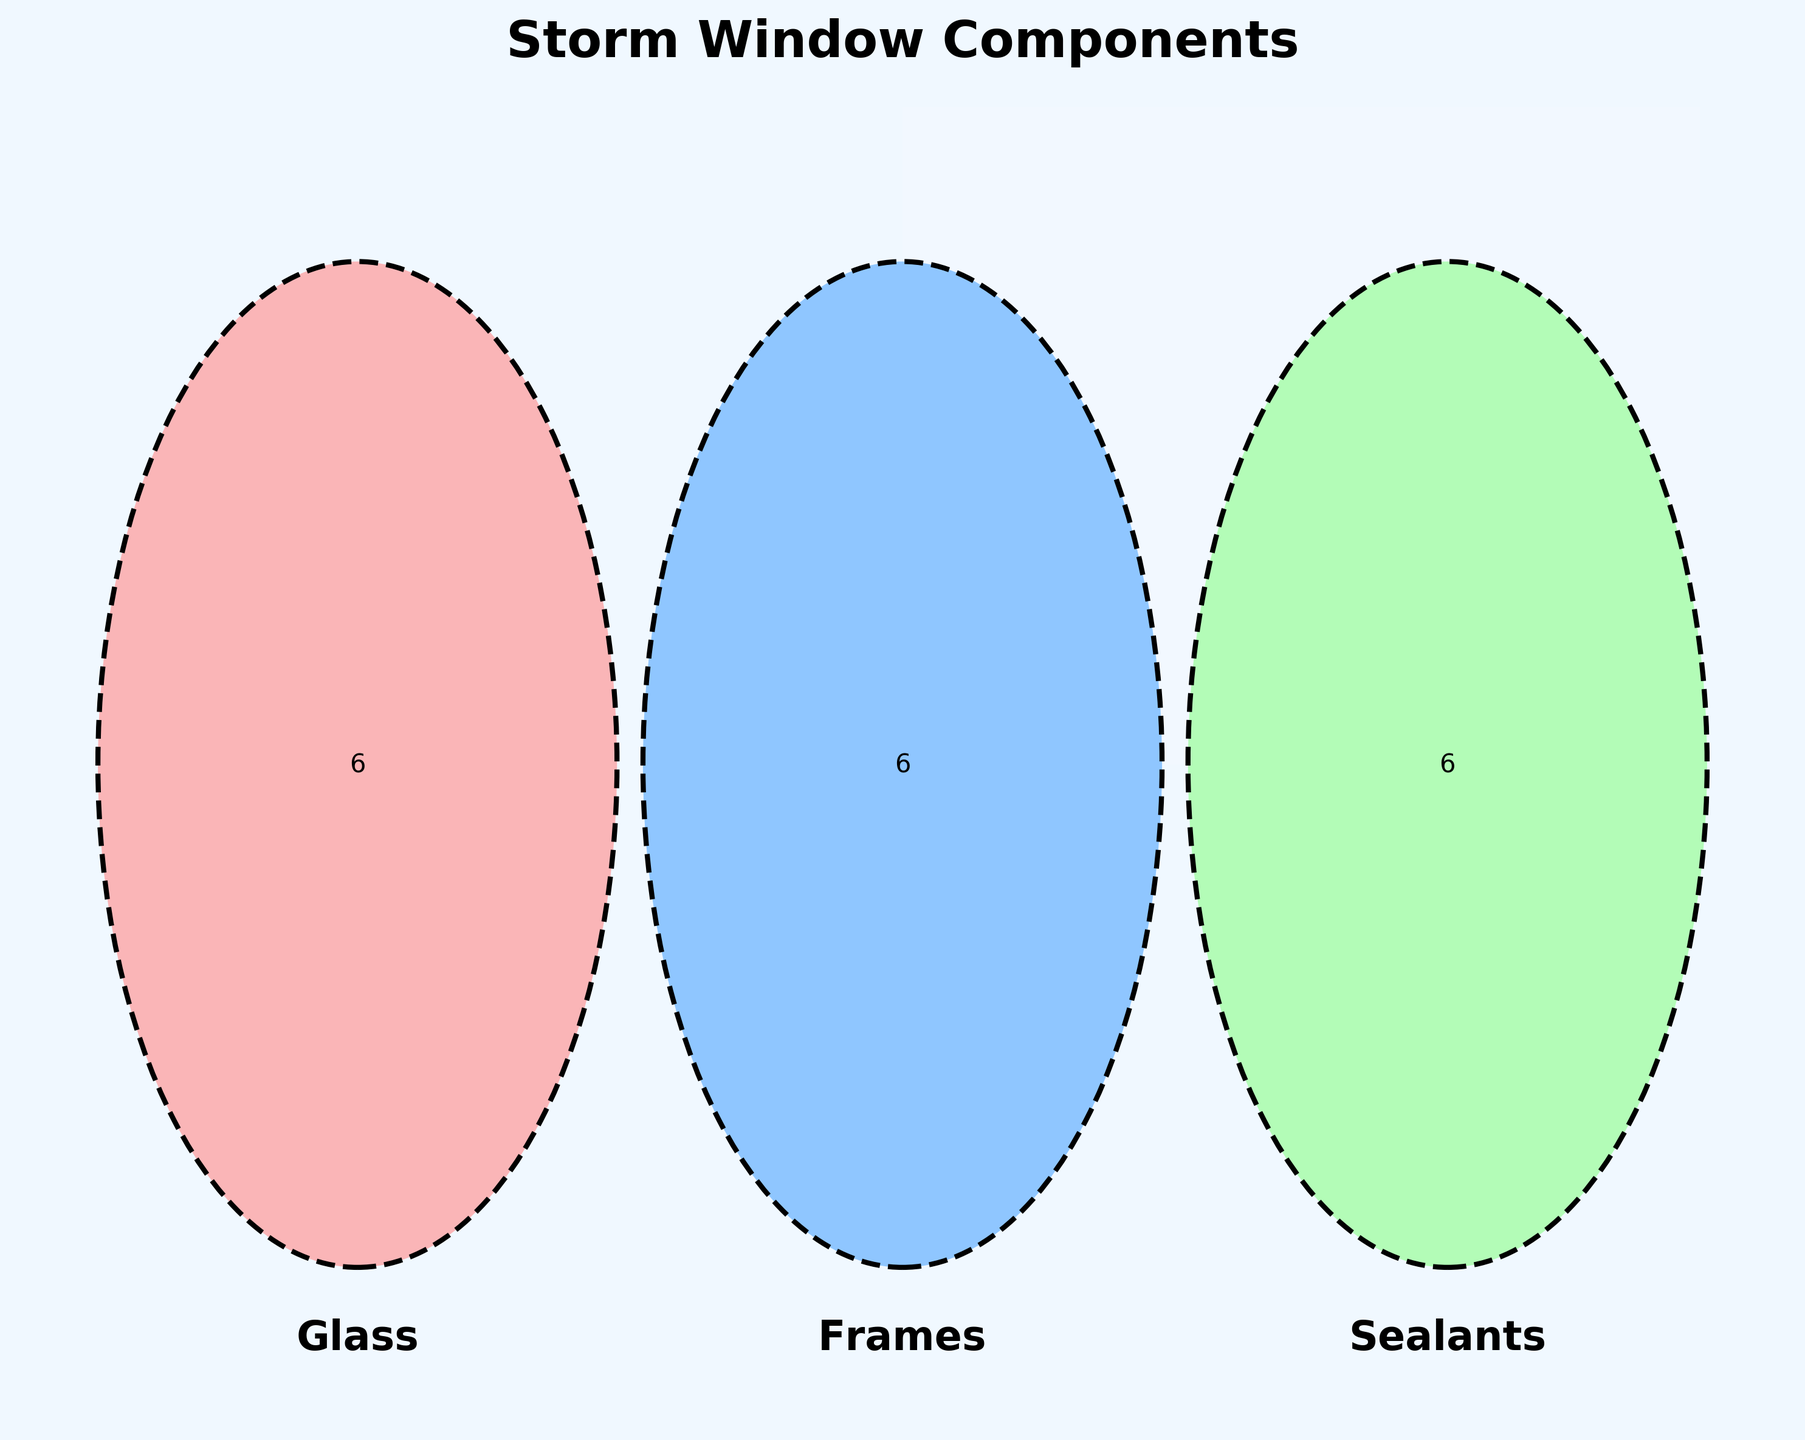What are the three main categories shown in the Venn Diagram? The Venn Diagram has labels indicating the three main categories represented by three circles. These labels are 'Glass', 'Frames', and 'Sealants'.
Answer: Glass, Frames, Sealants Identify one material that is only used in the 'Frames' category. The Venn Diagram shows that each category has unique materials. By looking specifically at the 'Frames' section (outside of any overlapping regions), we can identify unique materials like 'Aluminum', 'Vinyl', 'Fiberglass', 'Wood', 'Composite', and 'PVC'. 'Aluminum' is one example.
Answer: Aluminum Are there any materials shared between 'Glass' and 'Sealants'? To find shared materials between 'Glass' and 'Sealants', we look for the overlapping section between the two corresponding circles in the Venn Diagram. The diagram shows that there are no materials in the overlapping region between 'Glass' and 'Sealants'.
Answer: No Which materials are shared between all three categories? To spot materials shared among 'Glass', 'Frames', and 'Sealants', we examine the central overlapping region of the three circles. The Venn Diagram shows that there are no materials in this central overlapping area.
Answer: None Identify a material that is used in both 'Frames' and 'Sealants' but not in 'Glass'. We look at the overlapping section between 'Frames' and 'Sealants' while excluding the 'Glass' circle. The Venn Diagram shows the regions that belong only to 'Frames' and 'Sealants', but there is no overlap of these two excluding 'Glass'.
Answer: None Does 'Argon gas' overlap with any other categories? To answer this, we locate 'Argon gas' in the Venn Diagram and see if it lies in any overlapping regions. 'Argon gas' is placed solely within the 'Glass' circle, indicating it doesn't overlap with any other categories.
Answer: No How many unique materials are there in the 'Sealants' category? To find the number of unique materials in 'Sealants', we count the different materials listed in the 'Sealants' section, which are not part of overlapping regions. The materials are 'Silicone', 'Polyurethane', 'Butyl rubber', 'Polysulfide', 'Acrylic', and 'Latex'.
Answer: 6 